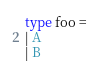<code> <loc_0><loc_0><loc_500><loc_500><_OCaml_>
type foo =
| A
| B
</code> 